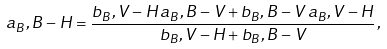<formula> <loc_0><loc_0><loc_500><loc_500>a _ { B } , B - H = \frac { b _ { B } , V - H \, a _ { B } , B - V + b _ { B } , B - V \, a _ { B } , V - H } { b _ { B } , V - H + b _ { B } , B - V } \, ,</formula> 